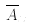Convert formula to latex. <formula><loc_0><loc_0><loc_500><loc_500>\overline { A } _ { x }</formula> 